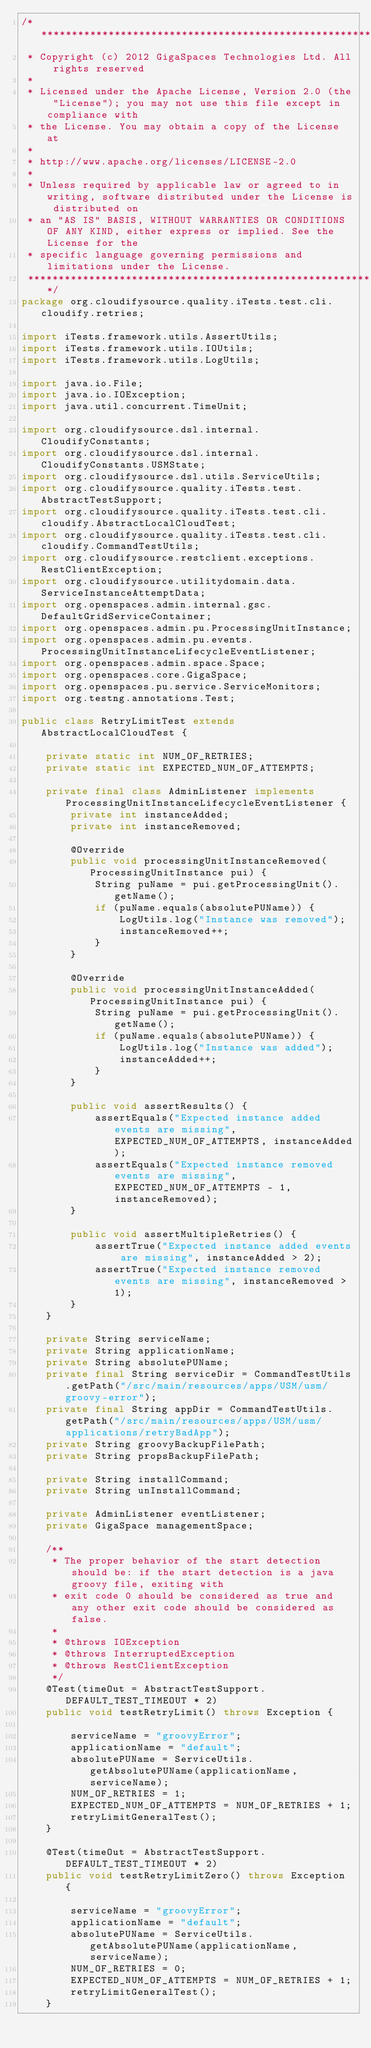<code> <loc_0><loc_0><loc_500><loc_500><_Java_>/*******************************************************************************
 * Copyright (c) 2012 GigaSpaces Technologies Ltd. All rights reserved
 *
 * Licensed under the Apache License, Version 2.0 (the "License"); you may not use this file except in compliance with
 * the License. You may obtain a copy of the License at
 *
 * http://www.apache.org/licenses/LICENSE-2.0
 *
 * Unless required by applicable law or agreed to in writing, software distributed under the License is distributed on
 * an "AS IS" BASIS, WITHOUT WARRANTIES OR CONDITIONS OF ANY KIND, either express or implied. See the License for the
 * specific language governing permissions and limitations under the License.
 ******************************************************************************/
package org.cloudifysource.quality.iTests.test.cli.cloudify.retries;

import iTests.framework.utils.AssertUtils;
import iTests.framework.utils.IOUtils;
import iTests.framework.utils.LogUtils;

import java.io.File;
import java.io.IOException;
import java.util.concurrent.TimeUnit;

import org.cloudifysource.dsl.internal.CloudifyConstants;
import org.cloudifysource.dsl.internal.CloudifyConstants.USMState;
import org.cloudifysource.dsl.utils.ServiceUtils;
import org.cloudifysource.quality.iTests.test.AbstractTestSupport;
import org.cloudifysource.quality.iTests.test.cli.cloudify.AbstractLocalCloudTest;
import org.cloudifysource.quality.iTests.test.cli.cloudify.CommandTestUtils;
import org.cloudifysource.restclient.exceptions.RestClientException;
import org.cloudifysource.utilitydomain.data.ServiceInstanceAttemptData;
import org.openspaces.admin.internal.gsc.DefaultGridServiceContainer;
import org.openspaces.admin.pu.ProcessingUnitInstance;
import org.openspaces.admin.pu.events.ProcessingUnitInstanceLifecycleEventListener;
import org.openspaces.admin.space.Space;
import org.openspaces.core.GigaSpace;
import org.openspaces.pu.service.ServiceMonitors;
import org.testng.annotations.Test;

public class RetryLimitTest extends AbstractLocalCloudTest {

    private static int NUM_OF_RETRIES;
    private static int EXPECTED_NUM_OF_ATTEMPTS;

    private final class AdminListener implements ProcessingUnitInstanceLifecycleEventListener {
        private int instanceAdded;
        private int instanceRemoved;

        @Override
        public void processingUnitInstanceRemoved(ProcessingUnitInstance pui) {
            String puName = pui.getProcessingUnit().getName();
            if (puName.equals(absolutePUName)) {
                LogUtils.log("Instance was removed");
                instanceRemoved++;
            }
        }

        @Override
        public void processingUnitInstanceAdded(ProcessingUnitInstance pui) {
            String puName = pui.getProcessingUnit().getName();
            if (puName.equals(absolutePUName)) {
                LogUtils.log("Instance was added");
                instanceAdded++;
            }
        }

        public void assertResults() {
            assertEquals("Expected instance added events are missing", EXPECTED_NUM_OF_ATTEMPTS, instanceAdded);
            assertEquals("Expected instance removed events are missing", EXPECTED_NUM_OF_ATTEMPTS - 1, instanceRemoved);
        }

        public void assertMultipleRetries() {
            assertTrue("Expected instance added events are missing", instanceAdded > 2);
            assertTrue("Expected instance removed events are missing", instanceRemoved > 1);
        }
    }

    private String serviceName;
    private String applicationName;
    private String absolutePUName;
    private final String serviceDir = CommandTestUtils.getPath("/src/main/resources/apps/USM/usm/groovy-error");
    private final String appDir = CommandTestUtils.getPath("/src/main/resources/apps/USM/usm/applications/retryBadApp");
    private String groovyBackupFilePath;
    private String propsBackupFilePath;

    private String installCommand;
    private String unInstallCommand;

    private AdminListener eventListener;
    private GigaSpace managementSpace;

    /**
     * The proper behavior of the start detection should be: if the start detection is a java groovy file, exiting with
     * exit code 0 should be considered as true and any other exit code should be considered as false.
     *
     * @throws IOException
     * @throws InterruptedException
     * @throws RestClientException
     */
    @Test(timeOut = AbstractTestSupport.DEFAULT_TEST_TIMEOUT * 2)
    public void testRetryLimit() throws Exception {

        serviceName = "groovyError";
        applicationName = "default";
        absolutePUName = ServiceUtils.getAbsolutePUName(applicationName, serviceName);
        NUM_OF_RETRIES = 1;
        EXPECTED_NUM_OF_ATTEMPTS = NUM_OF_RETRIES + 1;
        retryLimitGeneralTest();
    }

    @Test(timeOut = AbstractTestSupport.DEFAULT_TEST_TIMEOUT * 2)
    public void testRetryLimitZero() throws Exception {

        serviceName = "groovyError";
        applicationName = "default";
        absolutePUName = ServiceUtils.getAbsolutePUName(applicationName, serviceName);
        NUM_OF_RETRIES = 0;
        EXPECTED_NUM_OF_ATTEMPTS = NUM_OF_RETRIES + 1;
        retryLimitGeneralTest();
    }
</code> 